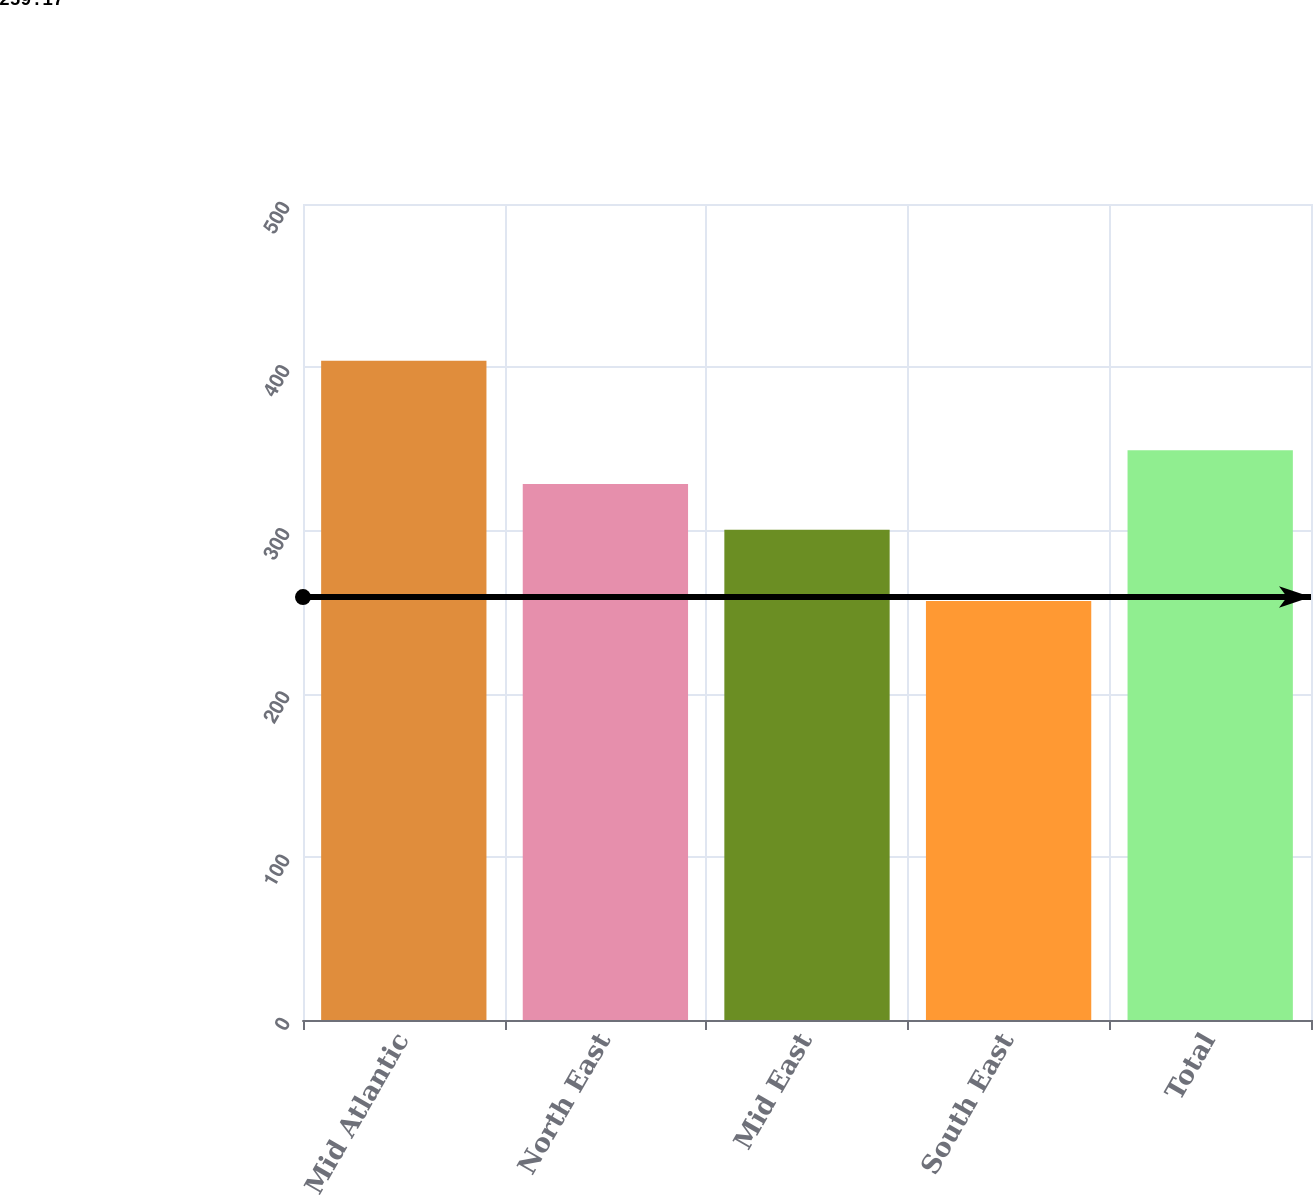Convert chart. <chart><loc_0><loc_0><loc_500><loc_500><bar_chart><fcel>Mid Atlantic<fcel>North East<fcel>Mid East<fcel>South East<fcel>Total<nl><fcel>404<fcel>328.4<fcel>300.4<fcel>256.7<fcel>349.1<nl></chart> 